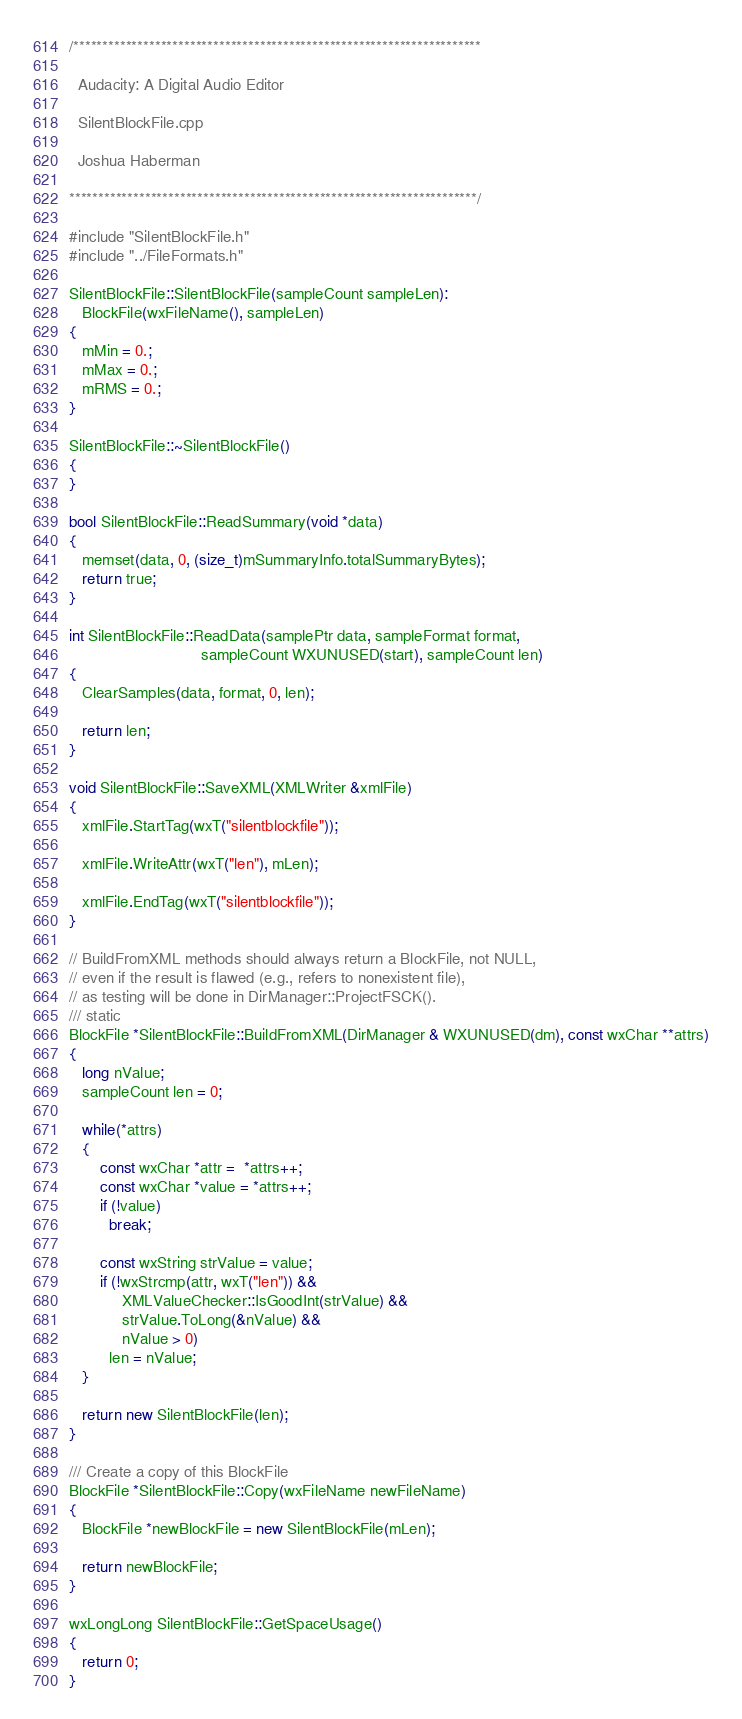<code> <loc_0><loc_0><loc_500><loc_500><_C++_>/**********************************************************************

  Audacity: A Digital Audio Editor

  SilentBlockFile.cpp

  Joshua Haberman

**********************************************************************/

#include "SilentBlockFile.h"
#include "../FileFormats.h"

SilentBlockFile::SilentBlockFile(sampleCount sampleLen):
   BlockFile(wxFileName(), sampleLen)
{
   mMin = 0.;
   mMax = 0.;
   mRMS = 0.;
}

SilentBlockFile::~SilentBlockFile()
{
}

bool SilentBlockFile::ReadSummary(void *data)
{
   memset(data, 0, (size_t)mSummaryInfo.totalSummaryBytes);
   return true;
}

int SilentBlockFile::ReadData(samplePtr data, sampleFormat format,
                              sampleCount WXUNUSED(start), sampleCount len)
{
   ClearSamples(data, format, 0, len);

   return len;
}

void SilentBlockFile::SaveXML(XMLWriter &xmlFile)
{
   xmlFile.StartTag(wxT("silentblockfile"));

   xmlFile.WriteAttr(wxT("len"), mLen);

   xmlFile.EndTag(wxT("silentblockfile"));
}

// BuildFromXML methods should always return a BlockFile, not NULL,  
// even if the result is flawed (e.g., refers to nonexistent file), 
// as testing will be done in DirManager::ProjectFSCK().
/// static
BlockFile *SilentBlockFile::BuildFromXML(DirManager & WXUNUSED(dm), const wxChar **attrs)
{
   long nValue;
   sampleCount len = 0;

   while(*attrs)
   {
       const wxChar *attr =  *attrs++;
       const wxChar *value = *attrs++;
       if (!value)
         break;

       const wxString strValue = value;
       if (!wxStrcmp(attr, wxT("len")) && 
            XMLValueChecker::IsGoodInt(strValue) && 
            strValue.ToLong(&nValue) && 
            nValue > 0) 
         len = nValue;
   }

   return new SilentBlockFile(len);
}

/// Create a copy of this BlockFile
BlockFile *SilentBlockFile::Copy(wxFileName newFileName)
{
   BlockFile *newBlockFile = new SilentBlockFile(mLen);

   return newBlockFile;
}

wxLongLong SilentBlockFile::GetSpaceUsage()
{
   return 0;
}

</code> 